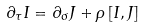Convert formula to latex. <formula><loc_0><loc_0><loc_500><loc_500>\partial _ { \tau } I = \partial _ { \sigma } J + \rho \left [ I , J \right ]</formula> 